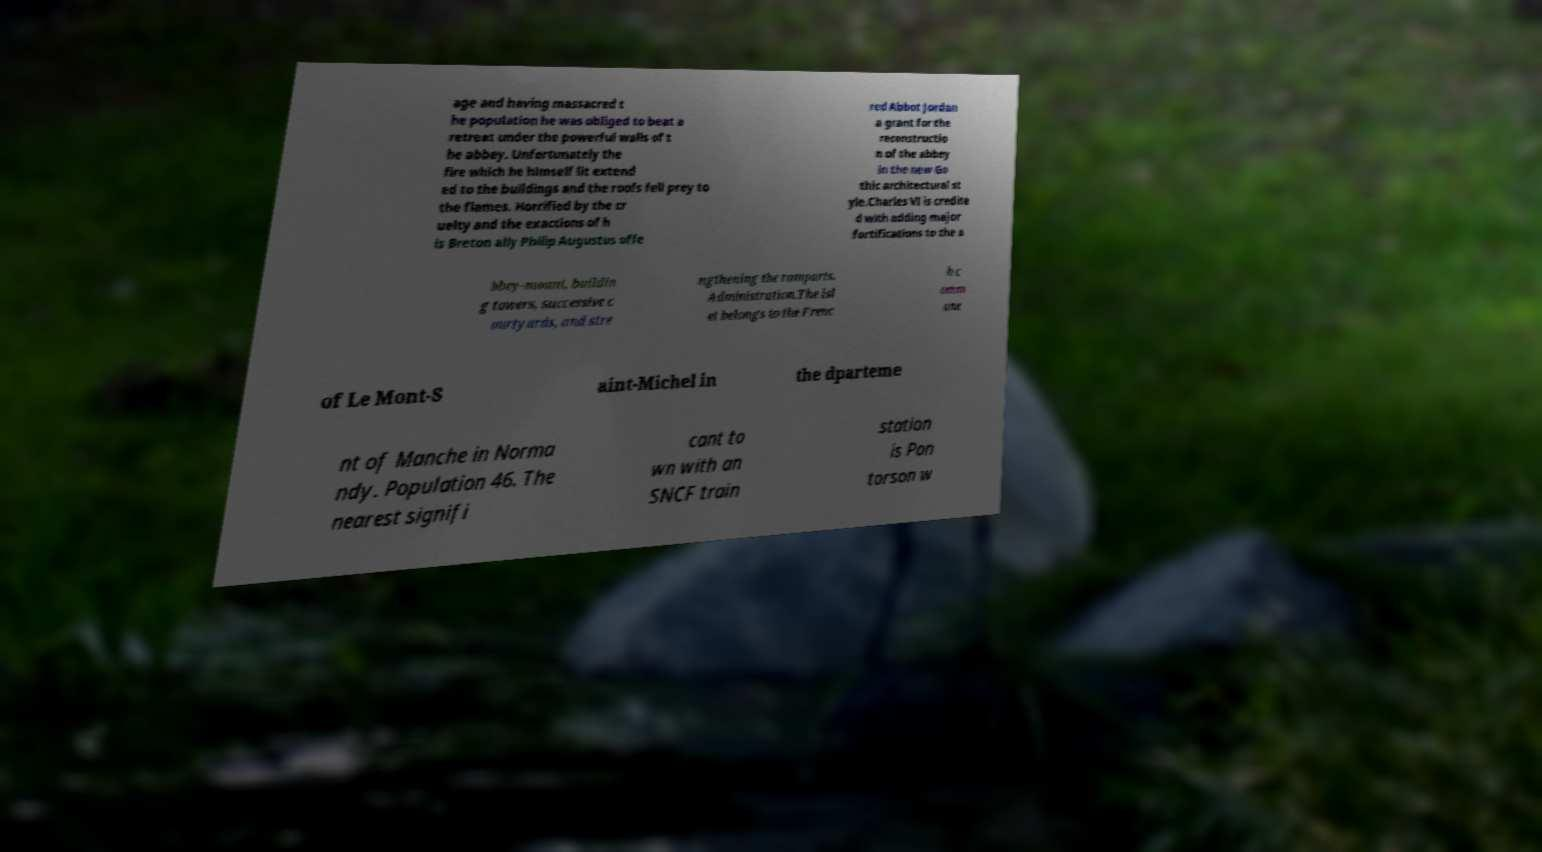Please read and relay the text visible in this image. What does it say? age and having massacred t he population he was obliged to beat a retreat under the powerful walls of t he abbey. Unfortunately the fire which he himself lit extend ed to the buildings and the roofs fell prey to the flames. Horrified by the cr uelty and the exactions of h is Breton ally Philip Augustus offe red Abbot Jordan a grant for the reconstructio n of the abbey in the new Go thic architectural st yle.Charles VI is credite d with adding major fortifications to the a bbey-mount, buildin g towers, successive c ourtyards, and stre ngthening the ramparts. Administration.The isl et belongs to the Frenc h c omm une of Le Mont-S aint-Michel in the dparteme nt of Manche in Norma ndy. Population 46. The nearest signifi cant to wn with an SNCF train station is Pon torson w 